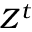<formula> <loc_0><loc_0><loc_500><loc_500>Z ^ { t }</formula> 